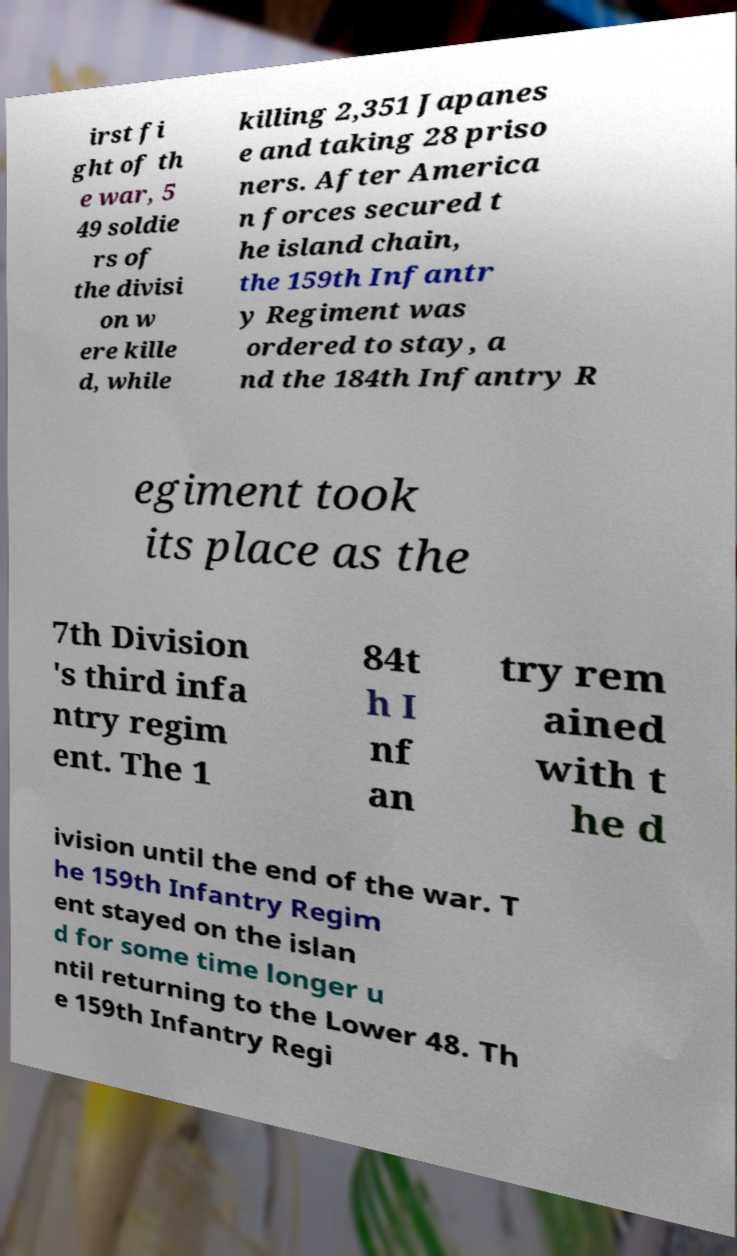Could you assist in decoding the text presented in this image and type it out clearly? irst fi ght of th e war, 5 49 soldie rs of the divisi on w ere kille d, while killing 2,351 Japanes e and taking 28 priso ners. After America n forces secured t he island chain, the 159th Infantr y Regiment was ordered to stay, a nd the 184th Infantry R egiment took its place as the 7th Division 's third infa ntry regim ent. The 1 84t h I nf an try rem ained with t he d ivision until the end of the war. T he 159th Infantry Regim ent stayed on the islan d for some time longer u ntil returning to the Lower 48. Th e 159th Infantry Regi 